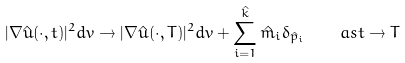<formula> <loc_0><loc_0><loc_500><loc_500>| \nabla \hat { u } ( \cdot , t ) | ^ { 2 } d v \to | \nabla \hat { u } ( \cdot , T ) | ^ { 2 } d v + \sum _ { i = 1 } ^ { \hat { k } } \hat { m } _ { i } \delta _ { \hat { p } _ { i } } \quad a s t \to T</formula> 